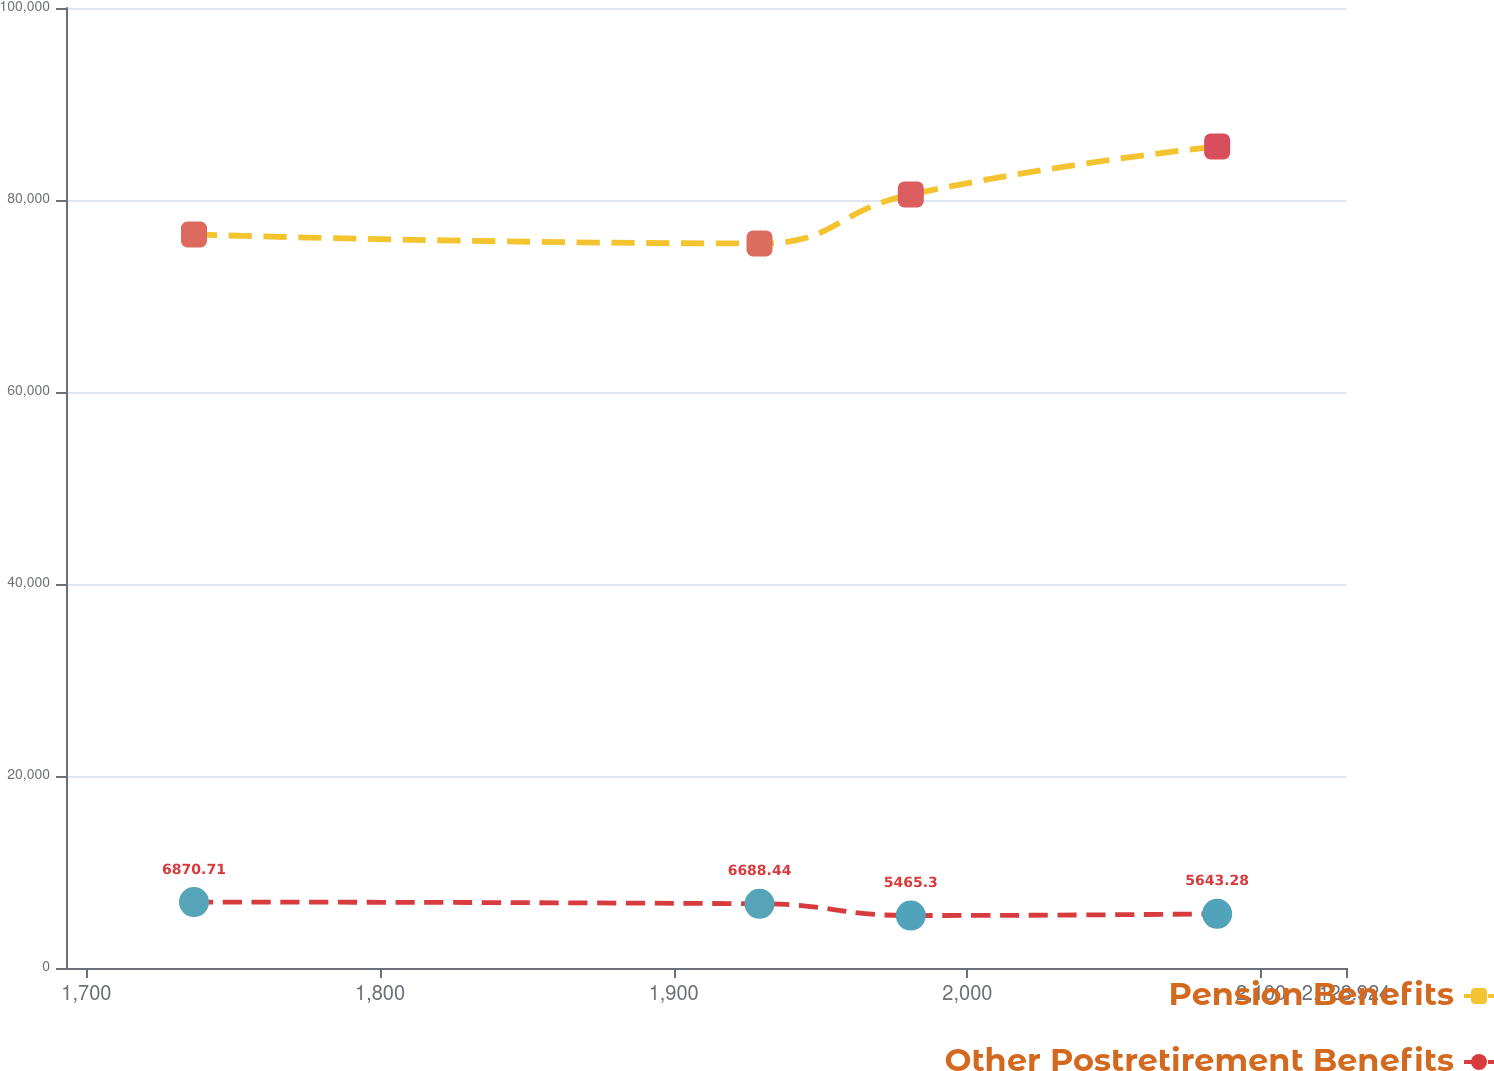Convert chart. <chart><loc_0><loc_0><loc_500><loc_500><line_chart><ecel><fcel>Pension Benefits<fcel>Other Postretirement Benefits<nl><fcel>1736.65<fcel>76408.4<fcel>6870.71<nl><fcel>1929.22<fcel>75472.9<fcel>6688.44<nl><fcel>1980.73<fcel>80579<fcel>5465.3<nl><fcel>2085.05<fcel>85577.9<fcel>5643.28<nl><fcel>2172.51<fcel>84642.4<fcel>5785.25<nl></chart> 